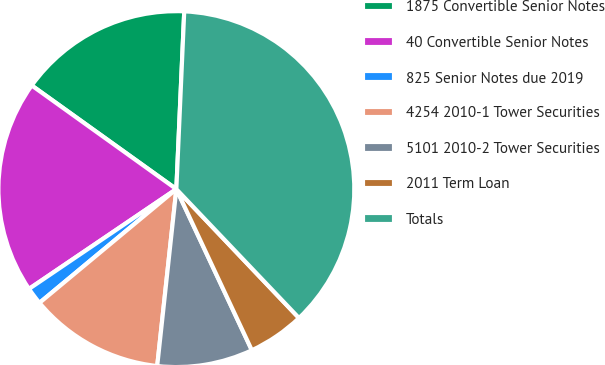<chart> <loc_0><loc_0><loc_500><loc_500><pie_chart><fcel>1875 Convertible Senior Notes<fcel>40 Convertible Senior Notes<fcel>825 Senior Notes due 2019<fcel>4254 2010-1 Tower Securities<fcel>5101 2010-2 Tower Securities<fcel>2011 Term Loan<fcel>Totals<nl><fcel>15.81%<fcel>19.37%<fcel>1.56%<fcel>12.25%<fcel>8.69%<fcel>5.13%<fcel>37.19%<nl></chart> 